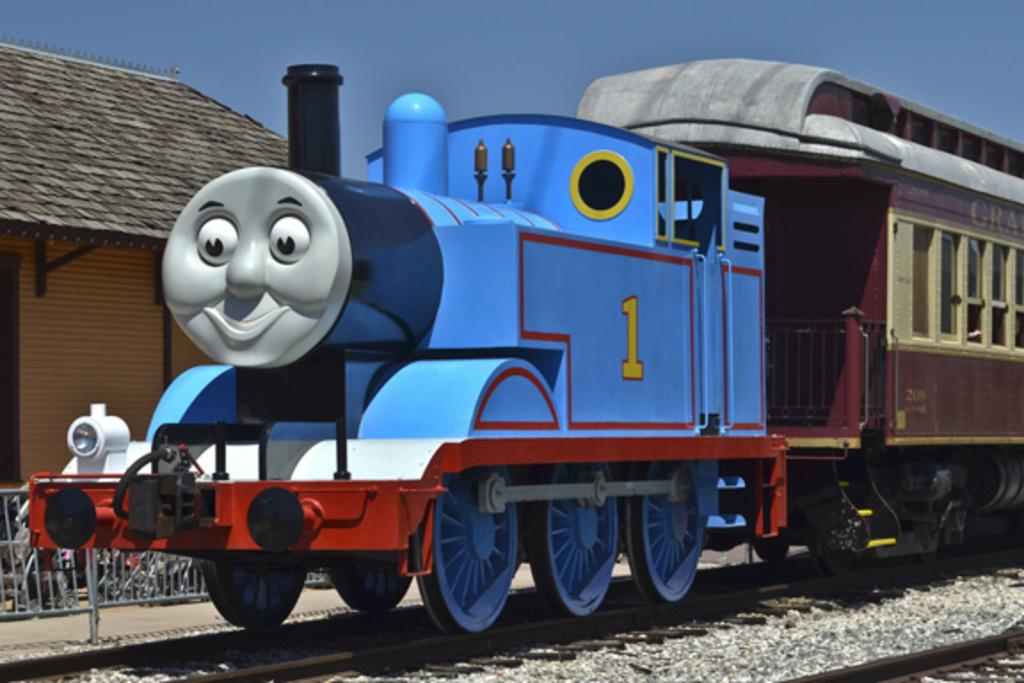What number on thomas?
Offer a terse response. 1. What number is on the train?
Your answer should be very brief. 1. 